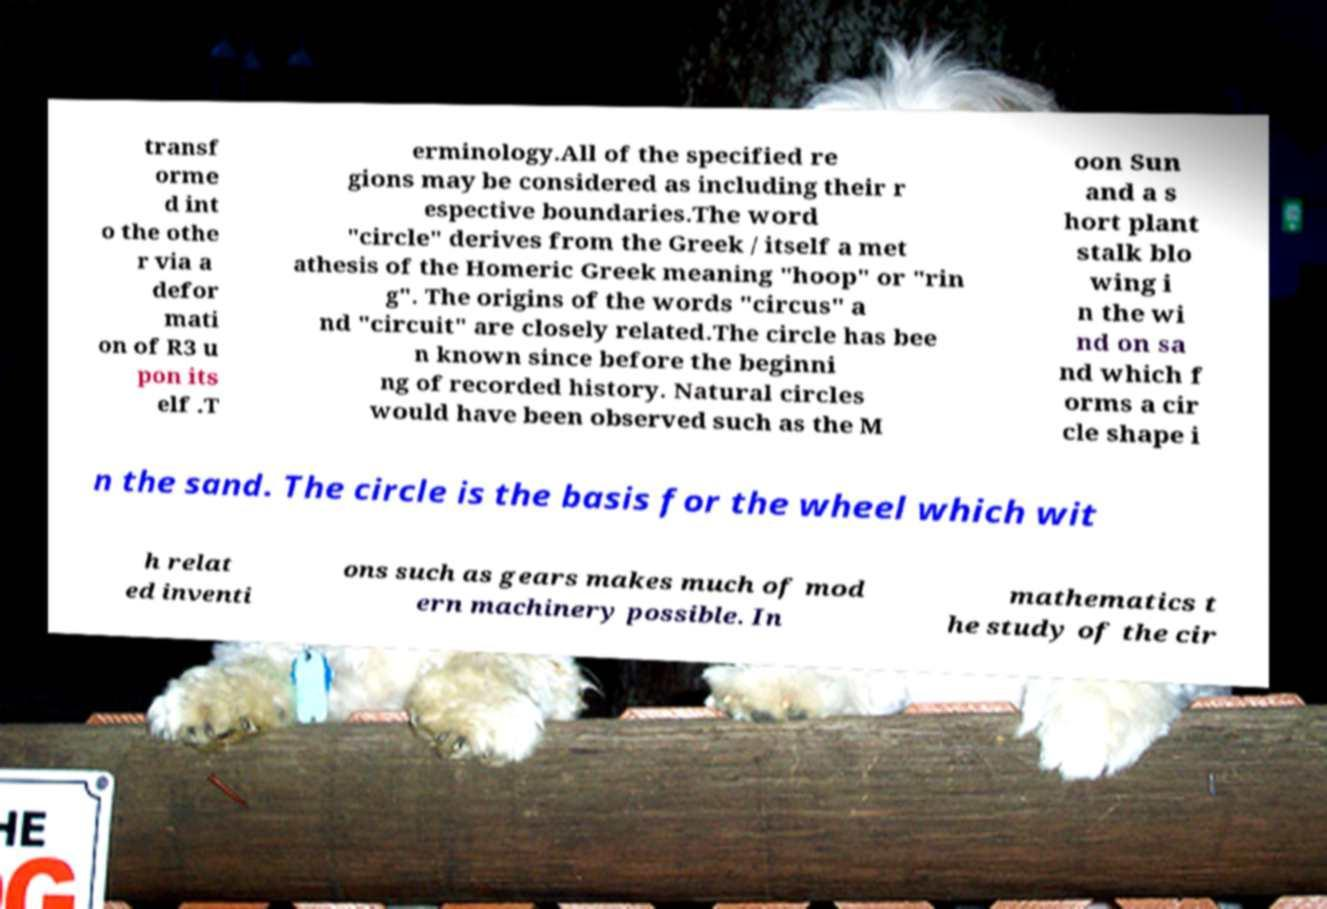Can you read and provide the text displayed in the image?This photo seems to have some interesting text. Can you extract and type it out for me? transf orme d int o the othe r via a defor mati on of R3 u pon its elf .T erminology.All of the specified re gions may be considered as including their r espective boundaries.The word "circle" derives from the Greek / itself a met athesis of the Homeric Greek meaning "hoop" or "rin g". The origins of the words "circus" a nd "circuit" are closely related.The circle has bee n known since before the beginni ng of recorded history. Natural circles would have been observed such as the M oon Sun and a s hort plant stalk blo wing i n the wi nd on sa nd which f orms a cir cle shape i n the sand. The circle is the basis for the wheel which wit h relat ed inventi ons such as gears makes much of mod ern machinery possible. In mathematics t he study of the cir 